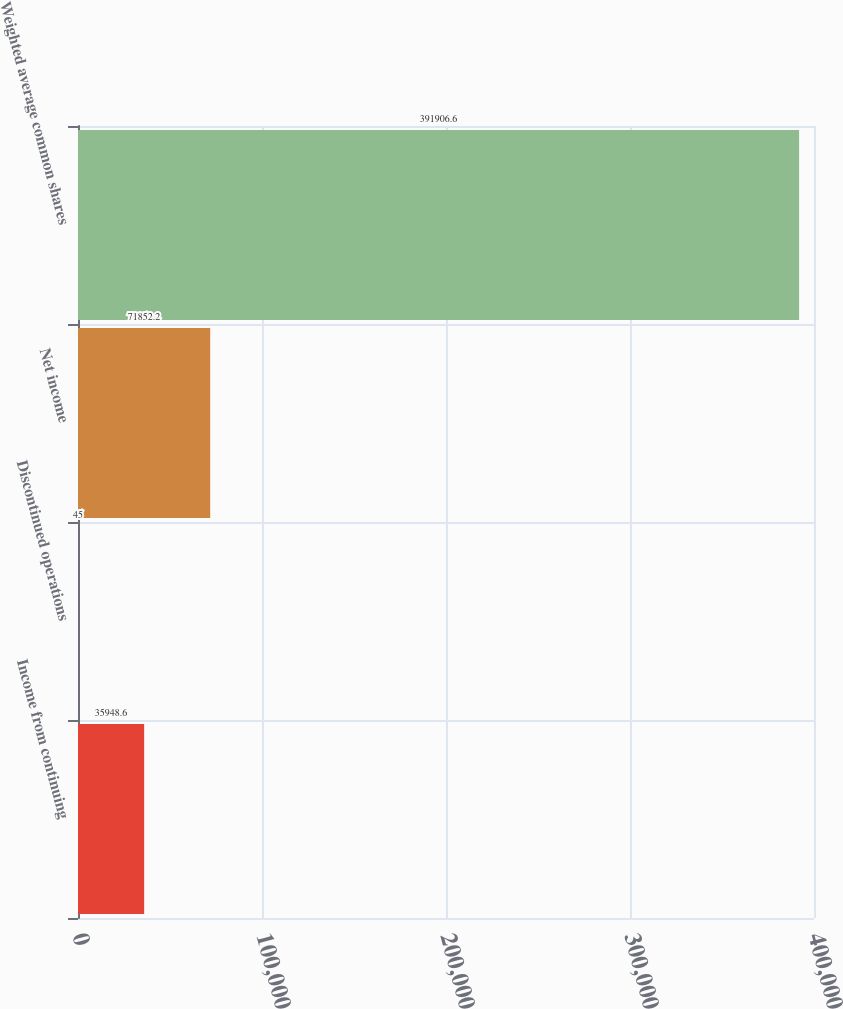Convert chart to OTSL. <chart><loc_0><loc_0><loc_500><loc_500><bar_chart><fcel>Income from continuing<fcel>Discontinued operations<fcel>Net income<fcel>Weighted average common shares<nl><fcel>35948.6<fcel>45<fcel>71852.2<fcel>391907<nl></chart> 